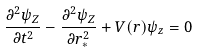Convert formula to latex. <formula><loc_0><loc_0><loc_500><loc_500>\frac { \partial ^ { 2 } \psi _ { Z } } { \partial t ^ { 2 } } - \frac { \partial ^ { 2 } \psi _ { Z } } { \partial r _ { * } ^ { 2 } } + V ( r ) \psi _ { z } = 0</formula> 